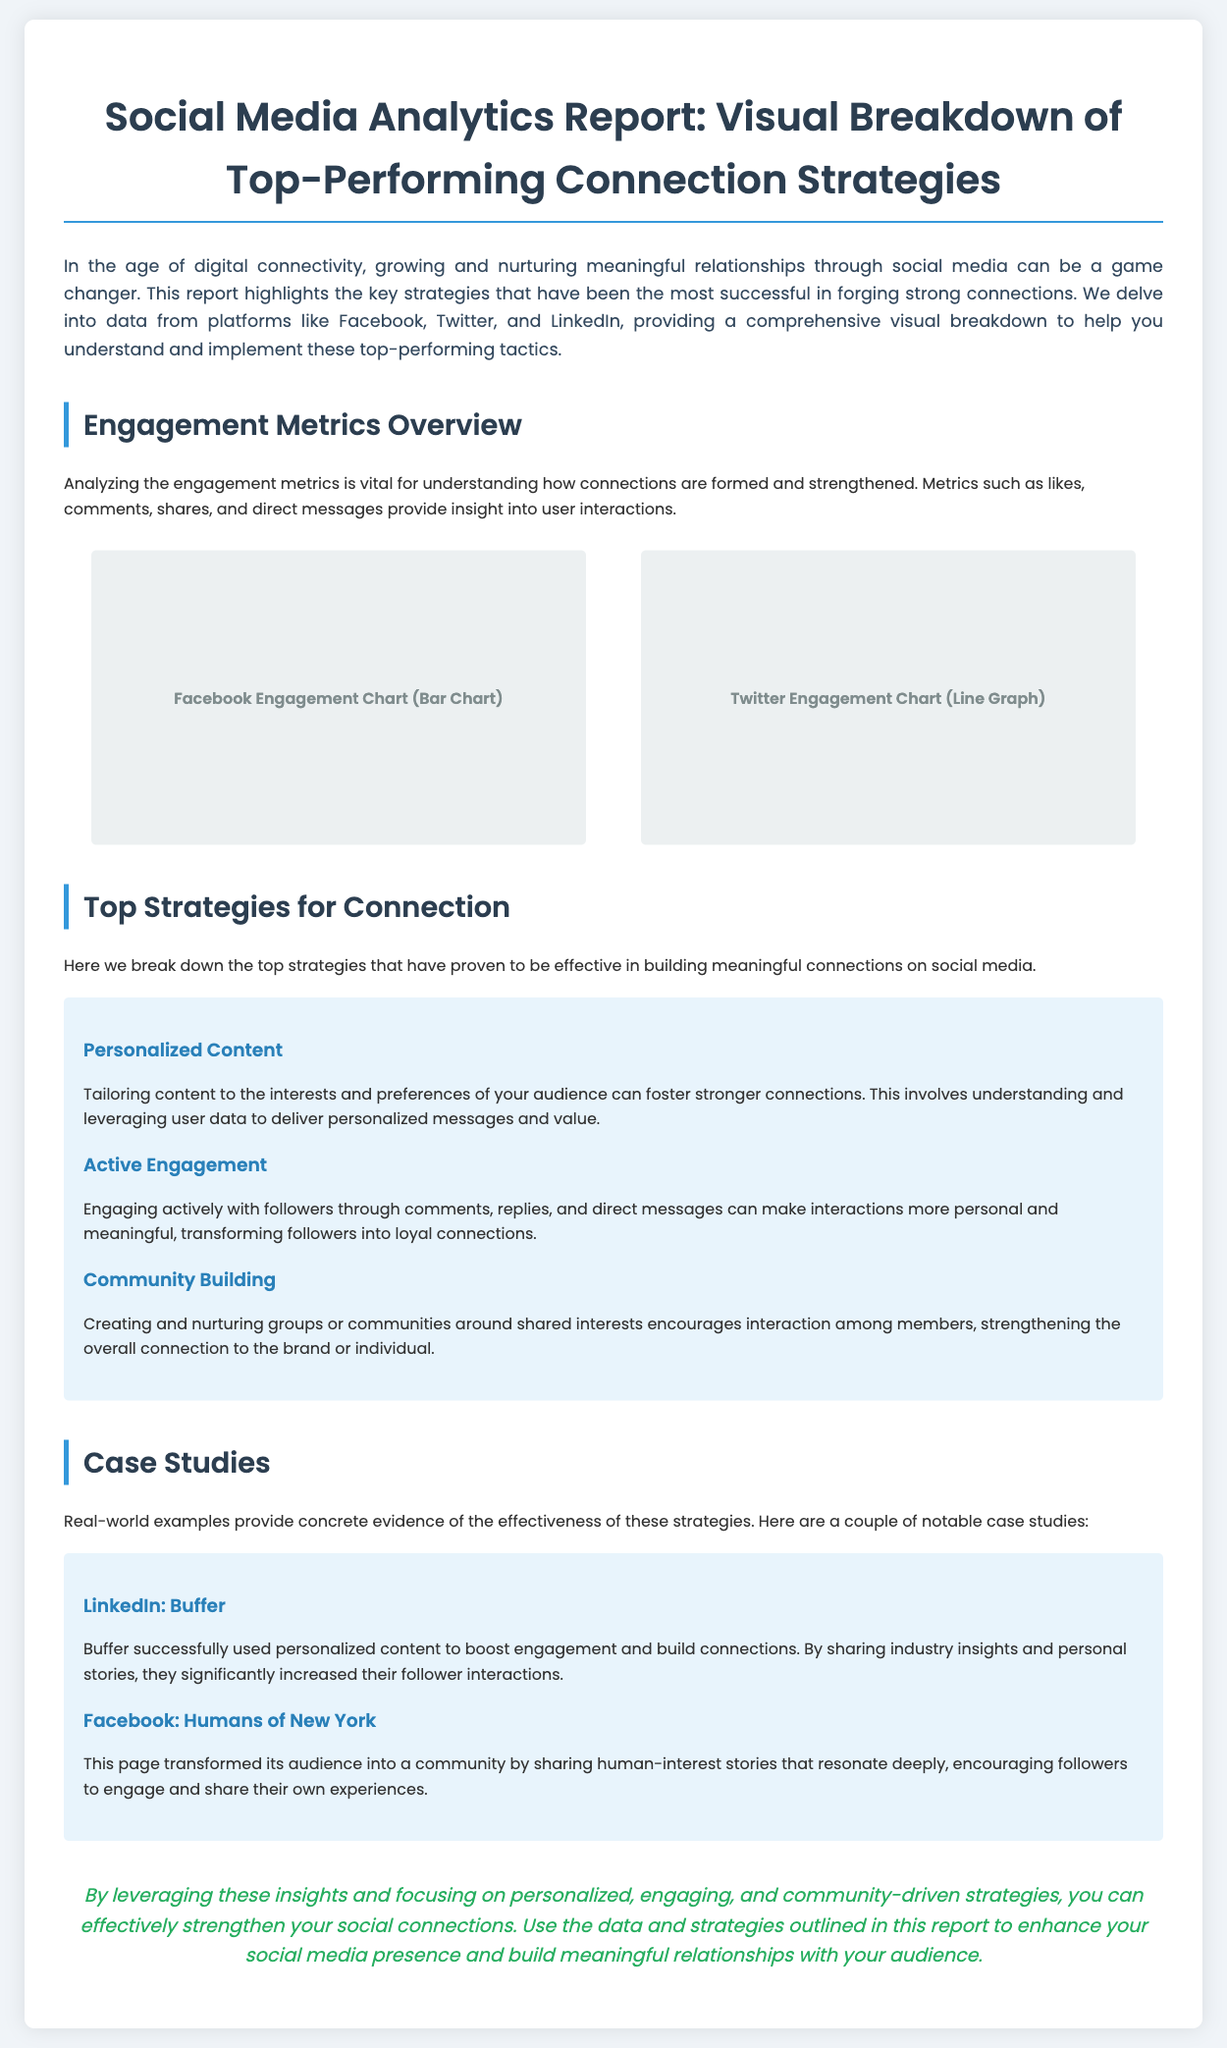What is the title of the report? The title is explicitly stated at the top of the document as the main heading.
Answer: Social Media Analytics Report: Visual Breakdown of Top-Performing Connection Strategies Which social media platforms are analyzed in the report? The platforms analyzed are mentioned in the introduction section of the document.
Answer: Facebook, Twitter, and LinkedIn What is the first top strategy listed for connection? The first strategy is detailed in the section about top strategies for connection.
Answer: Personalized Content Which case study highlights the use of personalized content? The case study examples provide a specific instance of applying strategies.
Answer: LinkedIn: Buffer What is the primary color used for section headings? The color can be identified in the styling of the headings throughout the document.
Answer: #2980b9 How many case studies are presented in the document? The number of case studies is noted in the dedicated case studies section.
Answer: Two What does the conclusion emphasize as a focus area for strengthening connections? The conclusion summarizes key aspects to enhance connections as stated in its text.
Answer: Personalized, engaging, and community-driven strategies 